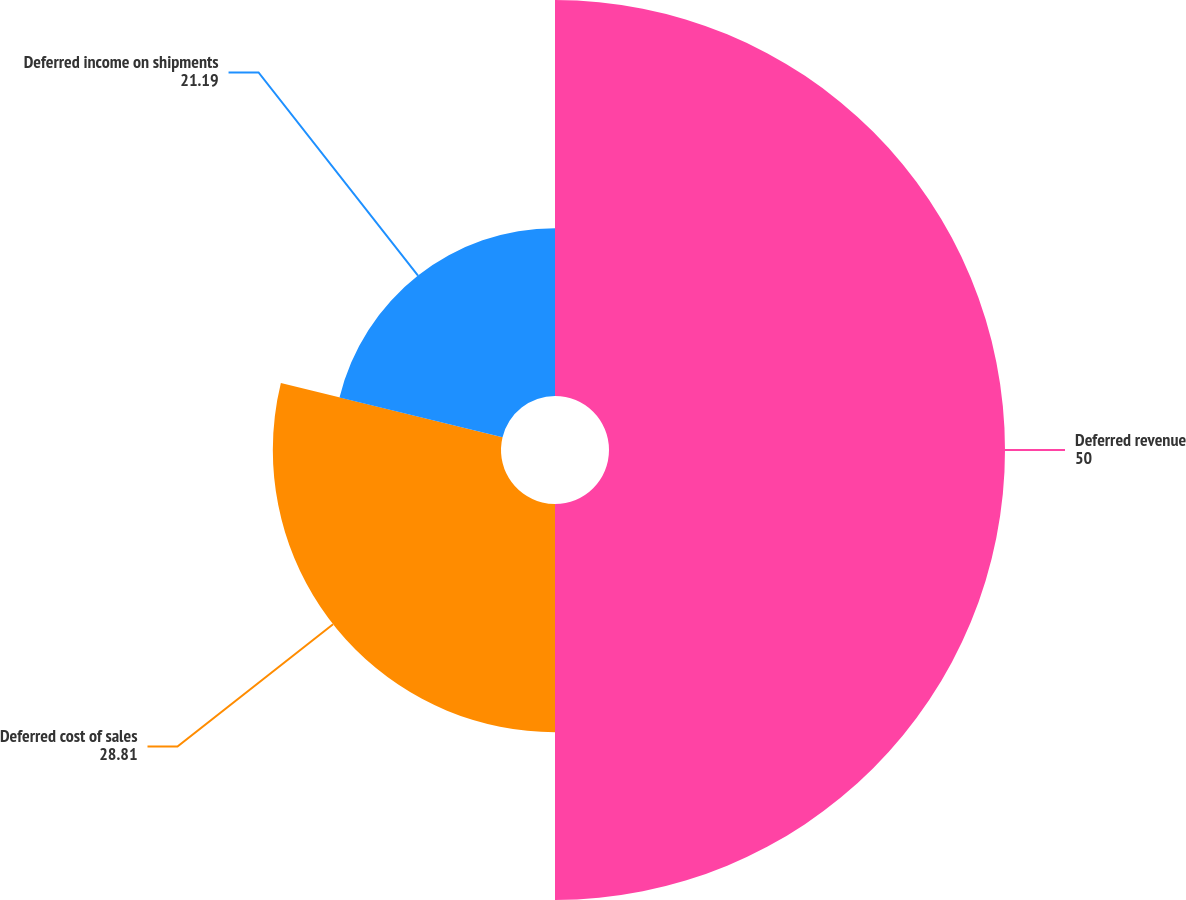Convert chart to OTSL. <chart><loc_0><loc_0><loc_500><loc_500><pie_chart><fcel>Deferred revenue<fcel>Deferred cost of sales<fcel>Deferred income on shipments<nl><fcel>50.0%<fcel>28.81%<fcel>21.19%<nl></chart> 